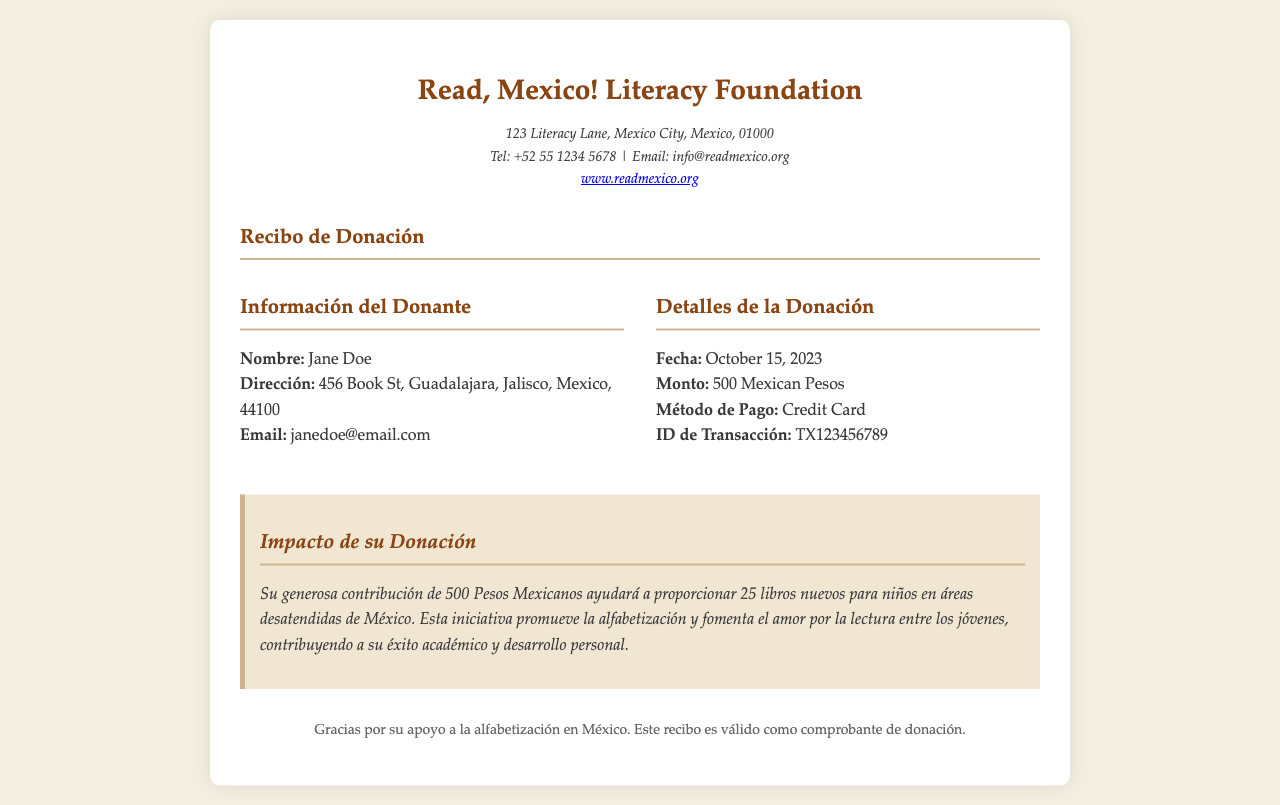what is the name of the organization? The name of the organization is provided at the top of the document in bold.
Answer: Read, Mexico! Literacy Foundation who is the donor? The donor's name is listed under the donor information section of the document.
Answer: Jane Doe what is the donation amount? The donation amount is specified in the details of the donation section.
Answer: 500 Mexican Pesos when was the donation made? The date of the donation is indicated in the donation details.
Answer: October 15, 2023 how many books will be provided with the donation? The impact statement specifies how many books will be purchased with the donation amount.
Answer: 25 libros nuevos what payment method was used for the donation? The payment method is mentioned in the donation details section of the document.
Answer: Credit Card what is the address of the donor? The address of the donor is included under the donor information section in the document.
Answer: 456 Book St, Guadalajara, Jalisco, Mexico, 44100 what is the impact of the donation on literacy? The impact statement describes the effect of the donation in terms of literacy support.
Answer: Proporcionar 25 libros nuevos what is the purpose of the receipt? The footer of the document describes the purpose of the receipt.
Answer: Comprobante de donación 